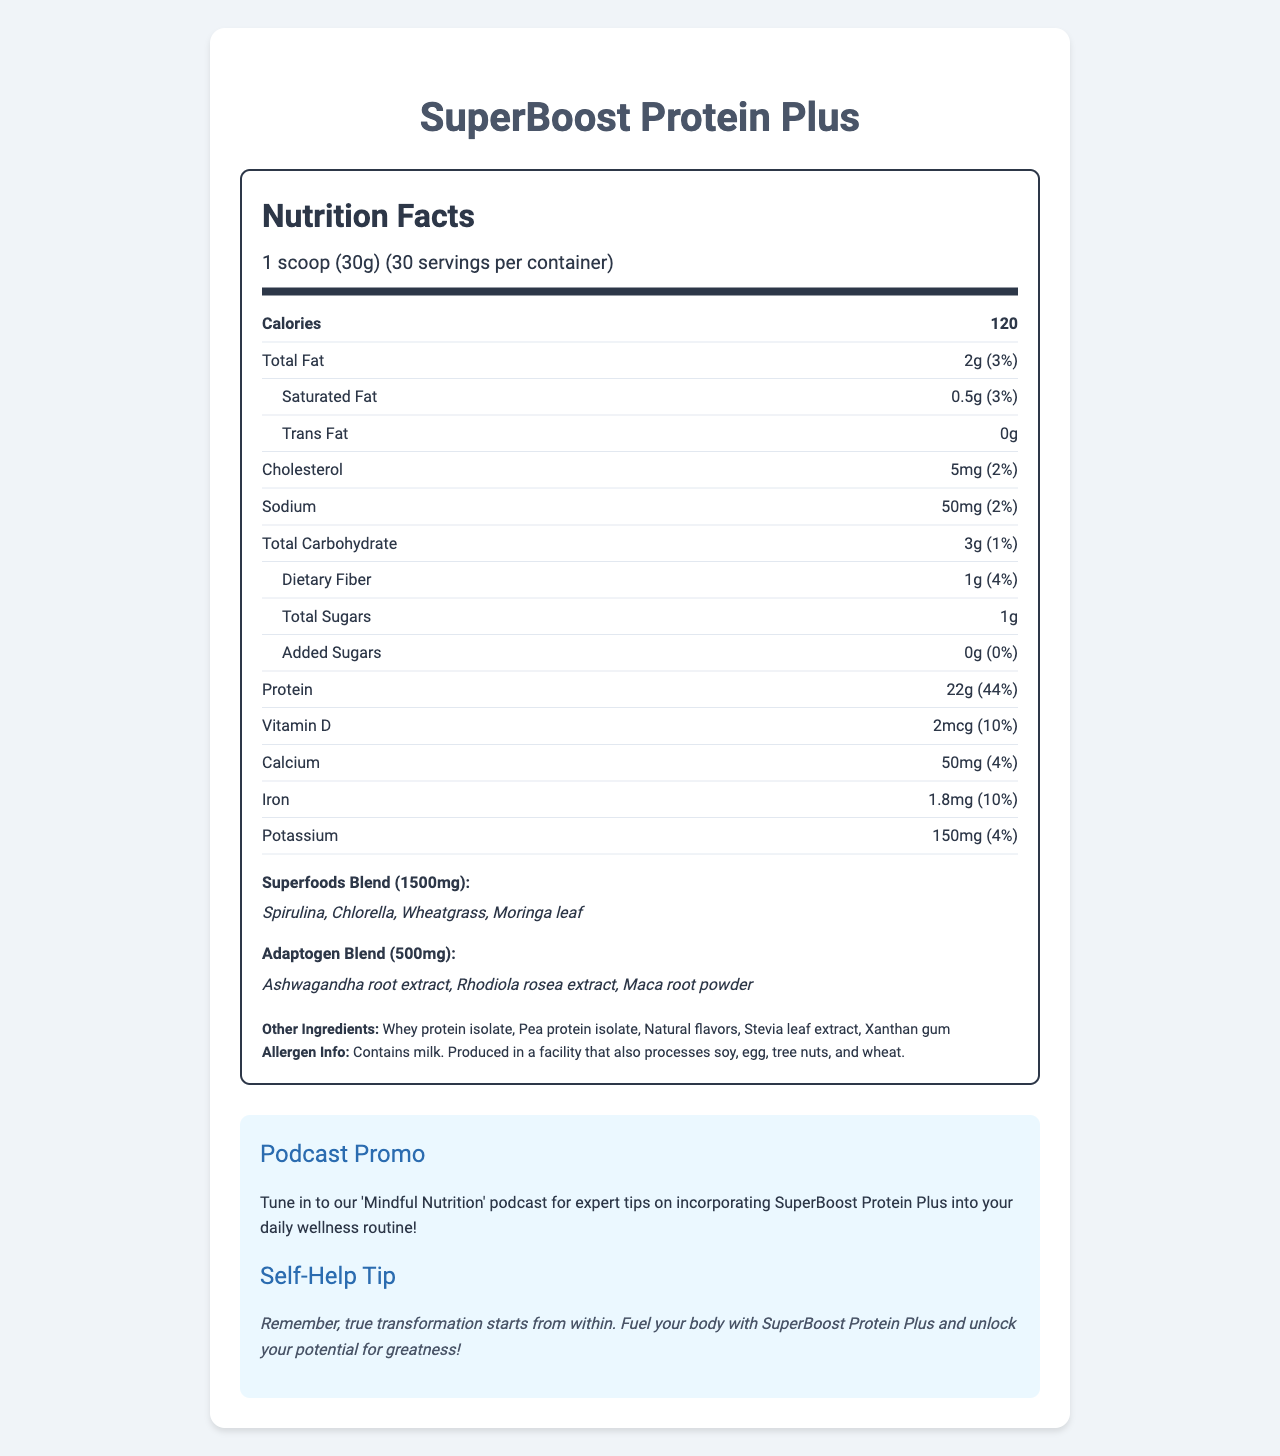what is the serving size for SuperBoost Protein Plus? The document lists the serving size as “1 scoop (30g)”.
Answer: 1 scoop (30g) how many servings are in each container of SuperBoost Protein Plus? The document mentions that there are 30 servings per container.
Answer: 30 what is the total amount of calories per serving? The document shows that each serving contains 120 calories.
Answer: 120 list three ingredients in the superfoods blend. The document lists the ingredients in the superfoods blend as Spirulina, Chlorella, Wheatgrass, and Moringa leaf.
Answer: Spirulina, Chlorella, Wheatgrass how much protein does each serving contain? According to the document, each serving contains 22g of protein.
Answer: 22g which of the following ingredients is NOT part of the adaptogen blend? A. Ashwagandha root extract B. Rhodiola rosea extract C. Moringa leaf D. Maca root powder The document lists Ashwagandha root extract, Rhodiola rosea extract, and Maca root powder as part of the adaptogen blend, but Moringa leaf is part of the superfoods blend, not the adaptogen blend.
Answer: C. Moringa leaf what percentage of the daily value for iron is provided by one serving? A. 4% B. 10% C. 20% D. 44% The document indicates that one serving provides 10% of the daily value for iron.
Answer: B. 10% does SuperBoost Protein Plus contain added sugars? The document specifies that there are 0g of added sugars in one serving.
Answer: No summarize the nutritional content and health benefits explained in the document The document provides comprehensive nutritional information about SuperBoost Protein Plus, detailing its serving size, calorie content, macronutrient levels, and specific vitamins and minerals. It highlights special blends of superfoods and adaptogens for added health benefits. Additionally, it includes a promo for a related podcast and a motivational self-help tip.
Answer: SuperBoost Protein Plus offers a balanced nutritional profile with 22g of protein per serving, essential vitamins, and minerals, while also including superfoods and adaptogens. It is low in calories, fat, sugars, and sodium. The product promotes overall wellness, enhanced by superfoods like Spirulina and adaptogens such as Ashwagandha, and provides practical wellness tips including a podcast recommendation. what is the amount of saturated fat per serving? As shown in the document, each serving contains 0.5g of saturated fat.
Answer: 0.5g does the product contain any allergens? The document states that the product contains milk and is produced in a facility that also processes soy, egg, tree nuts, and wheat.
Answer: Yes what is the purpose of the podcast mentioned in the document? The document promotes the 'Mindful Nutrition' podcast, which offers expert tips on how to include SuperBoost Protein Plus in one's wellness routine.
Answer: To provide expert tips on incorporating SuperBoost Protein Plus into the daily wellness routine what is the role of the self-help tip provided in the document? The self-help tip in the document emphasizes that true transformation starts within and encourages users to fuel their bodies with SuperBoost Protein Plus to unlock their potential.
Answer: To motivate and encourage users to fuel their body for transformation and greatness how much calcium is provided per serving? The document lists that there are 50mg of calcium per serving.
Answer: 50mg how many ingredients are listed in the “other ingredients” section? The document lists five other ingredients: Whey protein isolate, Pea protein isolate, Natural flavors, Stevia leaf extract, and Xanthan gum.
Answer: 5 how much vitamin D is in one serving? According to the document, each serving contains 2mcg of vitamin D.
Answer: 2mcg what are the flavoring agents used in SuperBoost Protein Plus? The document lists Stevia leaf extract and Natural flavors as part of the other ingredients.
Answer: Stevia leaf extract and Natural flavors when should one listen to the 'Mindful Nutrition' podcast for tips? The document mentions the 'Mindful Nutrition' podcast but does not provide specific times or guidelines on when to listen for tips.
Answer: Cannot be determined 